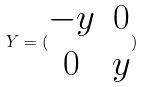<formula> <loc_0><loc_0><loc_500><loc_500>Y = ( \begin{matrix} - y & 0 \\ 0 & y \end{matrix} )</formula> 